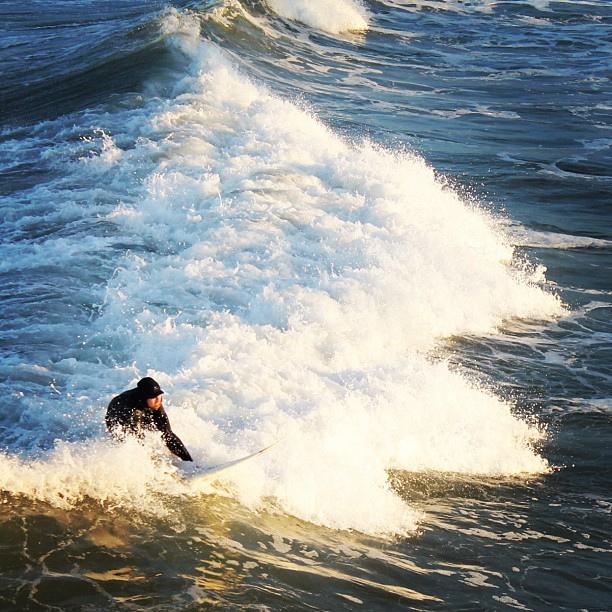Can this person swim?
Keep it brief. Yes. What activity is the person participating in?
Concise answer only. Surfing. Is the person wearing a wetsuit?
Keep it brief. Yes. 